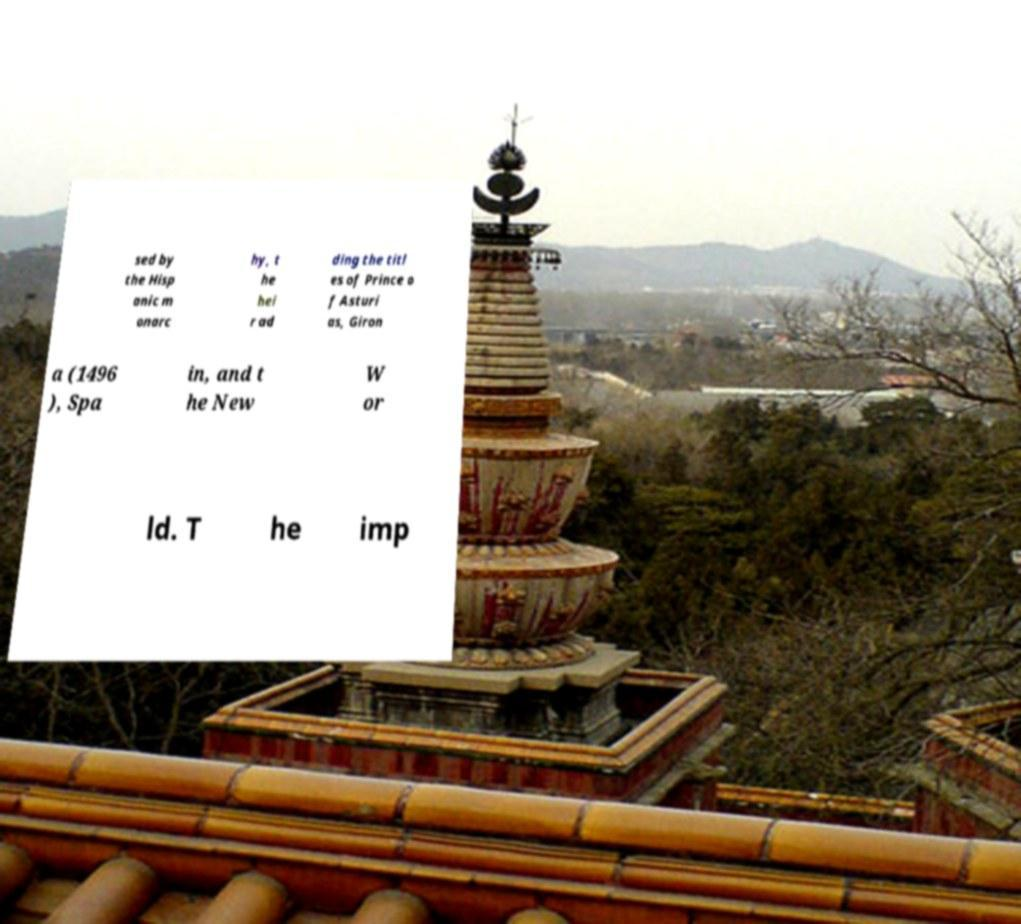For documentation purposes, I need the text within this image transcribed. Could you provide that? sed by the Hisp anic m onarc hy, t he hei r ad ding the titl es of Prince o f Asturi as, Giron a (1496 ), Spa in, and t he New W or ld. T he imp 